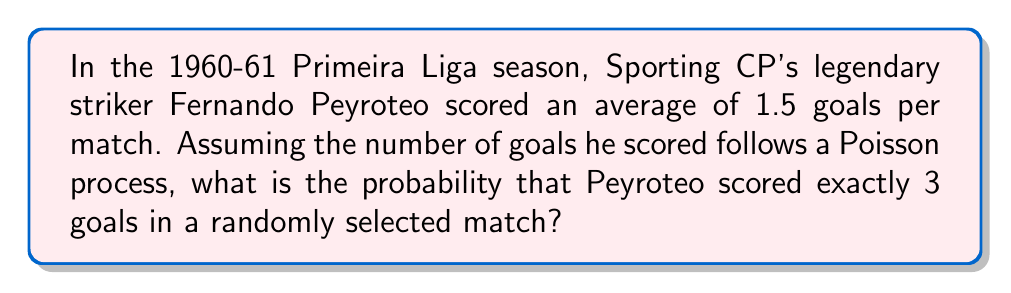Show me your answer to this math problem. Let's approach this step-by-step:

1) In a Poisson process, the number of events (in this case, goals) in a fixed interval follows a Poisson distribution.

2) The Poisson distribution is characterized by its rate parameter λ, which is the average number of events per interval. Here, λ = 1.5 goals per match.

3) The probability mass function of a Poisson distribution is given by:

   $$P(X = k) = \frac{e^{-λ} λ^k}{k!}$$

   where k is the number of events we're interested in (in this case, 3 goals).

4) Substituting our values:
   
   $$P(X = 3) = \frac{e^{-1.5} (1.5)^3}{3!}$$

5) Let's calculate this step-by-step:
   
   $$P(X = 3) = \frac{e^{-1.5} \cdot (1.5)^3}{3 \cdot 2 \cdot 1}$$
   
   $$= \frac{0.2231 \cdot 3.375}{6}$$
   
   $$= \frac{0.7530}{6}$$
   
   $$= 0.1255$$

6) Therefore, the probability is approximately 0.1255 or 12.55%.
Answer: 0.1255 